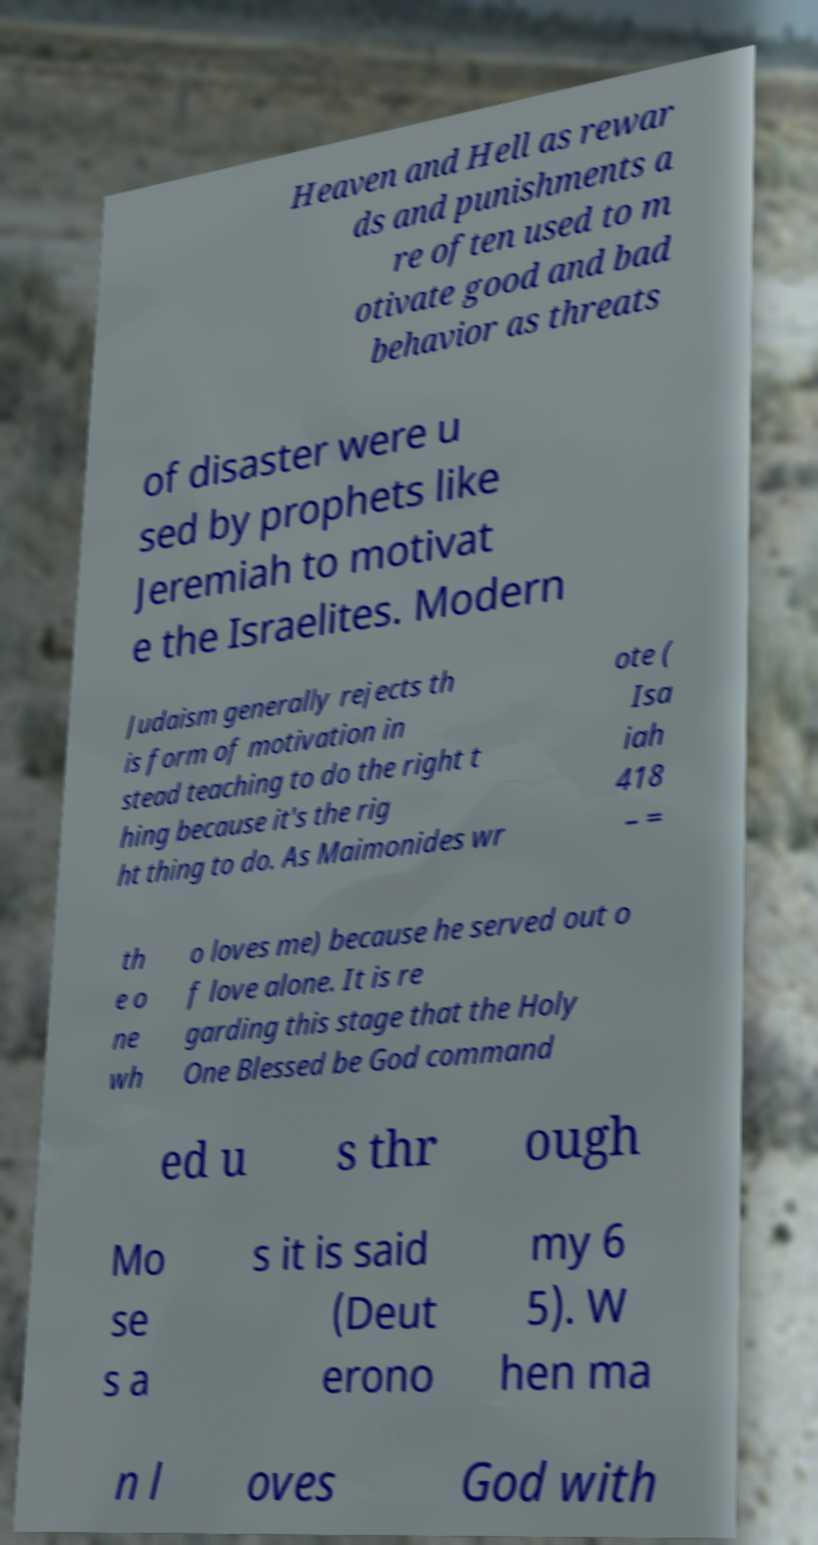For documentation purposes, I need the text within this image transcribed. Could you provide that? Heaven and Hell as rewar ds and punishments a re often used to m otivate good and bad behavior as threats of disaster were u sed by prophets like Jeremiah to motivat e the Israelites. Modern Judaism generally rejects th is form of motivation in stead teaching to do the right t hing because it's the rig ht thing to do. As Maimonides wr ote ( Isa iah 418 – = th e o ne wh o loves me) because he served out o f love alone. It is re garding this stage that the Holy One Blessed be God command ed u s thr ough Mo se s a s it is said (Deut erono my 6 5). W hen ma n l oves God with 